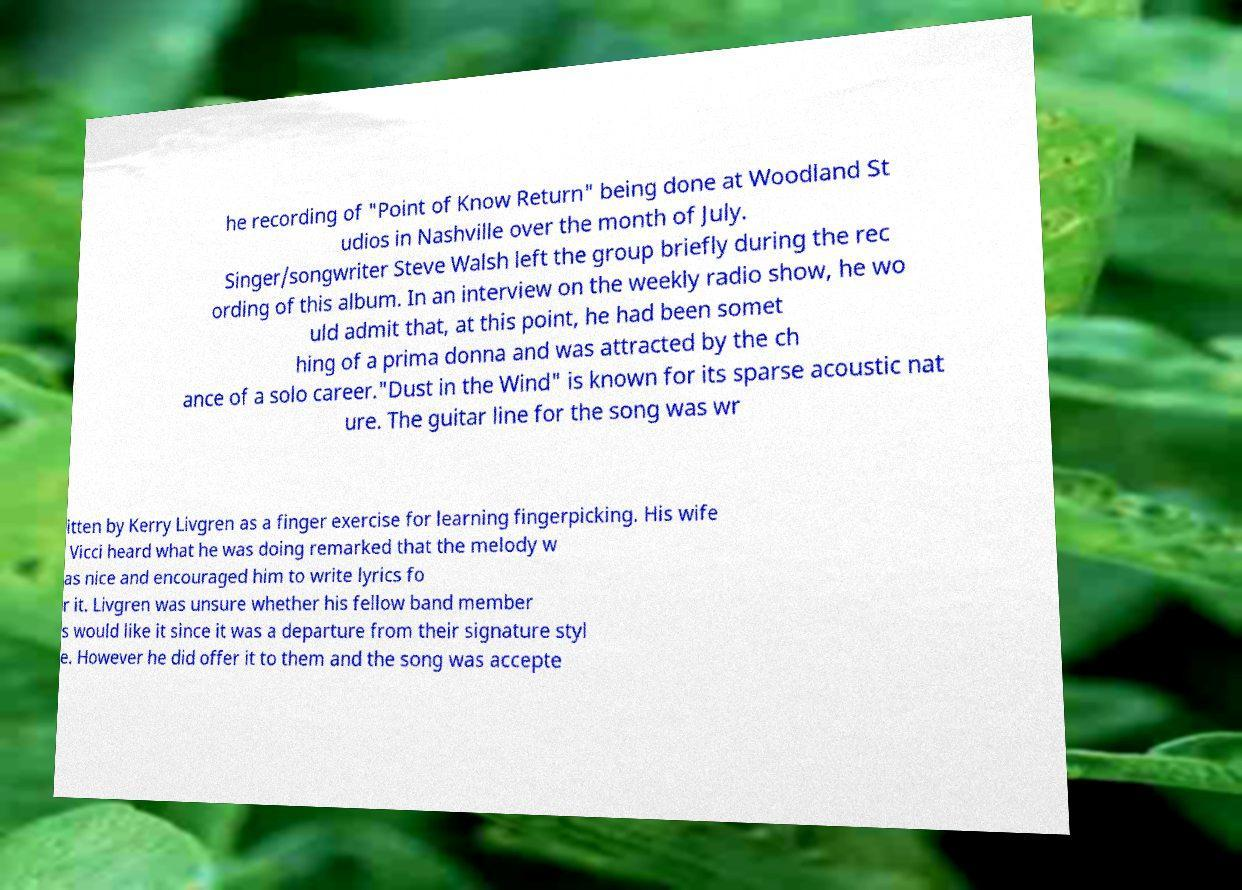Please identify and transcribe the text found in this image. he recording of "Point of Know Return" being done at Woodland St udios in Nashville over the month of July. Singer/songwriter Steve Walsh left the group briefly during the rec ording of this album. In an interview on the weekly radio show, he wo uld admit that, at this point, he had been somet hing of a prima donna and was attracted by the ch ance of a solo career."Dust in the Wind" is known for its sparse acoustic nat ure. The guitar line for the song was wr itten by Kerry Livgren as a finger exercise for learning fingerpicking. His wife Vicci heard what he was doing remarked that the melody w as nice and encouraged him to write lyrics fo r it. Livgren was unsure whether his fellow band member s would like it since it was a departure from their signature styl e. However he did offer it to them and the song was accepte 